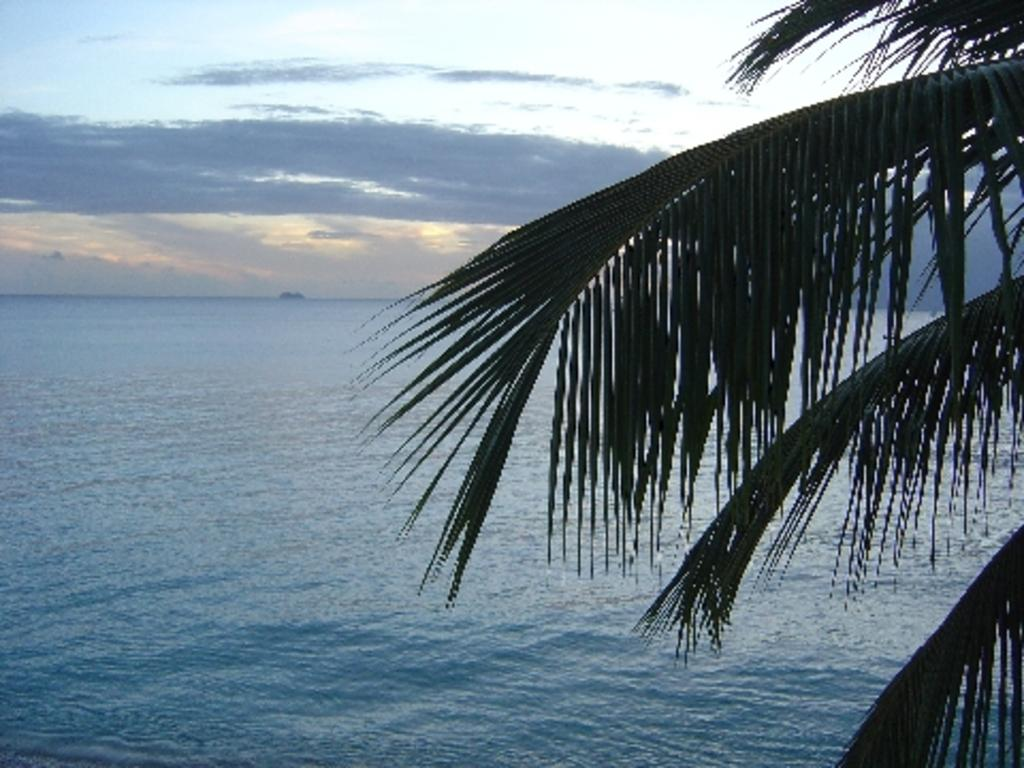What is the main subject of the image? The main subject of the image is a sea with water flowing. What can be seen on the right side of the image? There is a tree with leaves on the right side of the image. What is visible in the sky in the image? Clouds are visible in the sky. How much wealth is being exchanged in the market depicted in the image? There is no market or exchange of wealth depicted in the image; it features a sea, a tree, and clouds. 